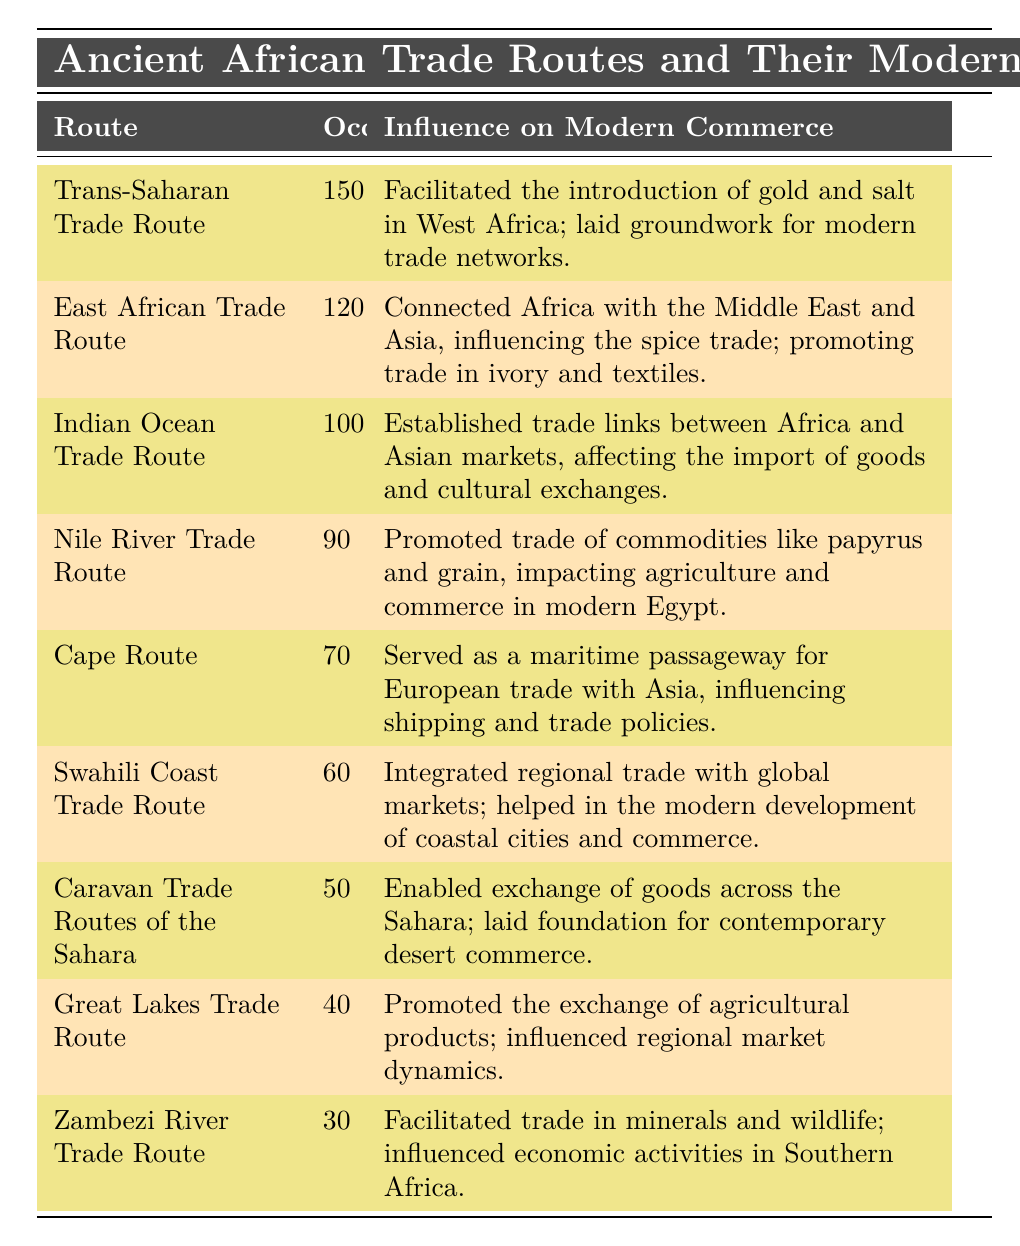What is the highest occurrence of an ancient trade route listed? From the table, we can see that the "Trans-Saharan Trade Route" has the highest occurrences noted, with a total of 150.
Answer: 150 Which trade route has the lowest occurrence? The "Zambezi River Trade Route" has the lowest occurrences recorded in the table, with a total of 30.
Answer: 30 How many total occurrences do the top three trade routes have? Summing the occurrences of the top three routes: Trans-Saharan (150) + East African (120) + Indian Ocean (100) gives us a total of 370 occurrences.
Answer: 370 Is the "Cape Route" more influential than the "Swahili Coast Trade Route" based on their modern commerce influences? The "Cape Route" has an occurrence of 70, while the "Swahili Coast Trade Route" is lower at 60. Thus, the "Cape Route" is indeed more influential in terms of occurrences.
Answer: Yes What is the average occurrence of all the trade routes? We first sum all the occurrences: 150 + 120 + 100 + 90 + 70 + 60 + 50 + 40 + 30 = 810. There are 9 routes, so we calculate the average as 810 divided by 9, resulting in 90.
Answer: 90 Which trade route's influence includes the introduction of gold and salt? The "Trans-Saharan Trade Route" is noted for facilitating the introduction of gold and salt into West Africa, as stated in the influence column.
Answer: Trans-Saharan Trade Route Is there a trade route associated with the exchange of ivory and textiles? Yes, the "East African Trade Route" is specifically mentioned as promoting trade in ivory and textiles.
Answer: Yes What is the combined occurrences of the "Caravan Trade Routes of the Sahara" and the "Great Lakes Trade Route"? Adding the occurrences of both routes: Caravan Trade Routes of the Sahara (50) + Great Lakes Trade Route (40) results in a combined total of 90 occurrences.
Answer: 90 Which trade route directly influenced agriculture in modern Egypt? The "Nile River Trade Route" promoted trade in commodities like papyrus and grain, which directly impacted agriculture in modern Egypt.
Answer: Nile River Trade Route 